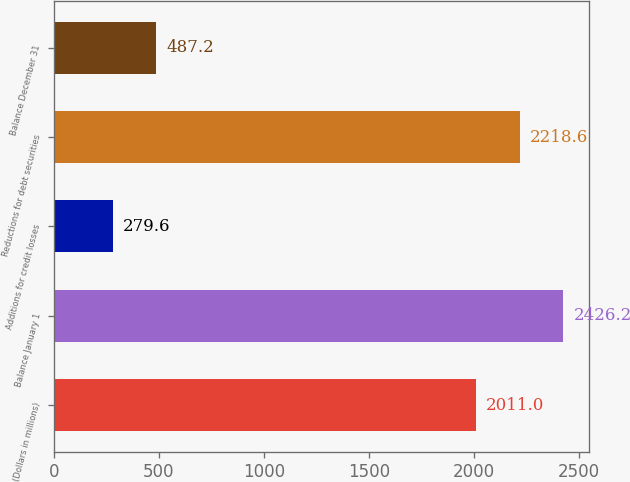Convert chart. <chart><loc_0><loc_0><loc_500><loc_500><bar_chart><fcel>(Dollars in millions)<fcel>Balance January 1<fcel>Additions for credit losses<fcel>Reductions for debt securities<fcel>Balance December 31<nl><fcel>2011<fcel>2426.2<fcel>279.6<fcel>2218.6<fcel>487.2<nl></chart> 